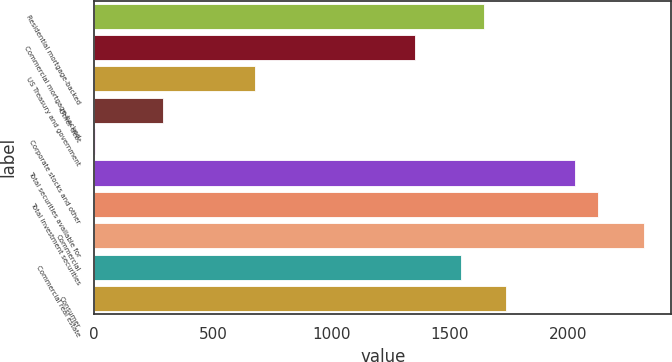Convert chart. <chart><loc_0><loc_0><loc_500><loc_500><bar_chart><fcel>Residential mortgage-backed<fcel>Commercial mortgage-backed<fcel>US Treasury and government<fcel>Other debt<fcel>Corporate stocks and other<fcel>Total securities available for<fcel>Total investment securities<fcel>Commercial<fcel>Commercial real estate<fcel>Consumer<nl><fcel>1641.5<fcel>1352<fcel>676.5<fcel>290.5<fcel>1<fcel>2027.5<fcel>2124<fcel>2317<fcel>1545<fcel>1738<nl></chart> 